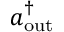Convert formula to latex. <formula><loc_0><loc_0><loc_500><loc_500>a _ { o u t } ^ { \dagger }</formula> 